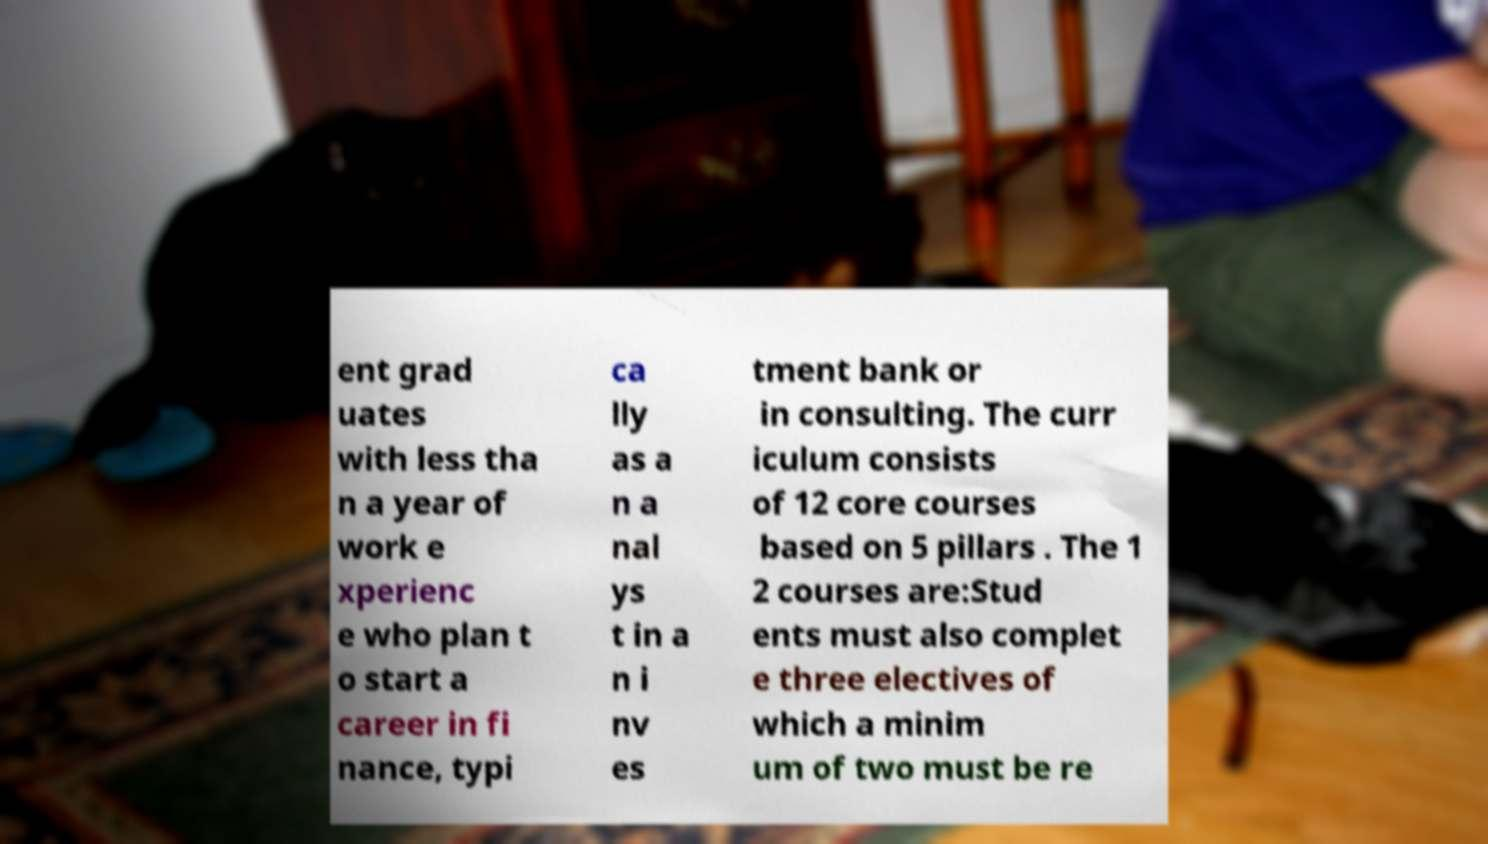What messages or text are displayed in this image? I need them in a readable, typed format. ent grad uates with less tha n a year of work e xperienc e who plan t o start a career in fi nance, typi ca lly as a n a nal ys t in a n i nv es tment bank or in consulting. The curr iculum consists of 12 core courses based on 5 pillars . The 1 2 courses are:Stud ents must also complet e three electives of which a minim um of two must be re 